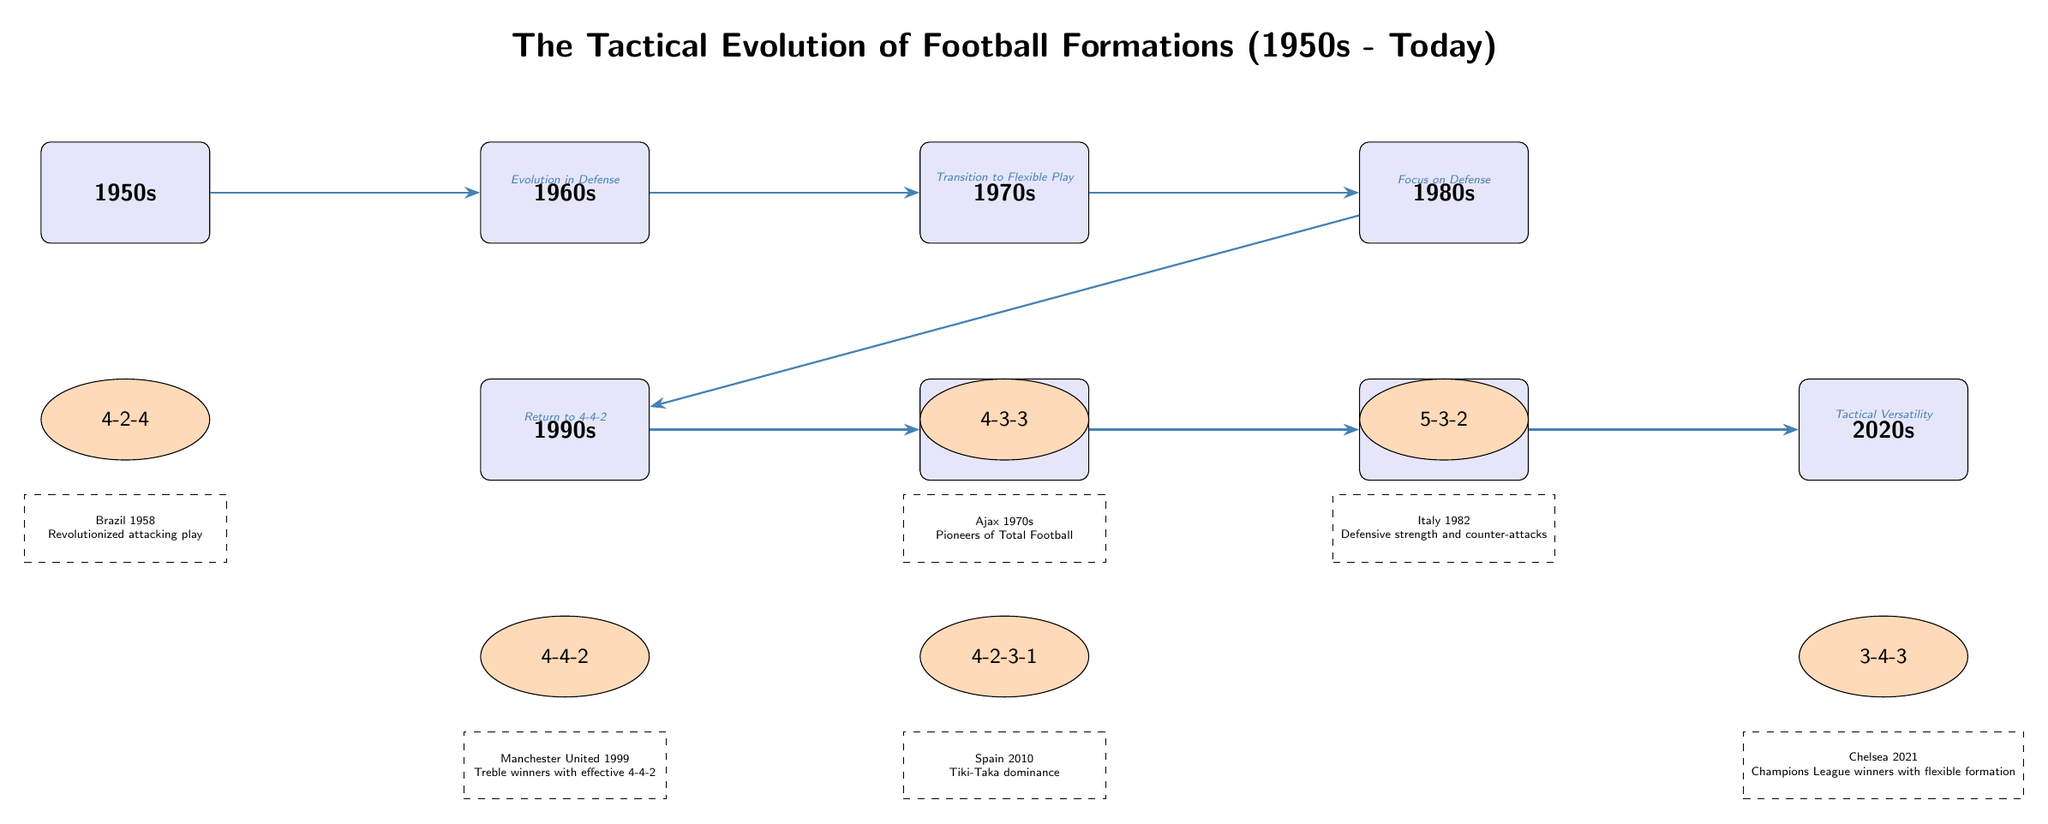What football formation is associated with the 1950s? The formation listed beneath the 1950s node in the diagram is 4-2-4. This directly relates to the node indicating the era.
Answer: 4-2-4 Which strategic change links the 1960s to the 1970s? The diagram shows an edge connecting the 1960s and 1970s with the label "Transition to Flexible Play." This indicates the strategic evolution from one era to the next.
Answer: Transition to Flexible Play What is the formation demonstrated during the 1990s? Under the 1990s node, the formation depicted is 4-4-2, as seen in the diagram.
Answer: 4-4-2 Which team is highlighted as a pioneer in Total Football during the 1970s? The example node below the 4-3-3 formation for the 1970s identifies Ajax 1970s as the pioneers of Total Football in that era.
Answer: Ajax 1970s How many edges are there in the diagram? By counting the connections between the era nodes, there are a total of seven edges shown connecting the different strategic changes.
Answer: 7 What formation is associated with tactical versatility in the 2020s? The diagram indicates that the 3-4-3 formation is represented beneath the 2020s node, linking it to tactical versatility.
Answer: 3-4-3 What strategic evolution is indicated between the 2000s and 2010s? The edge connecting the 2000s to the 2010s is labeled "Possession Play," showing that this was the strategic focus of that transition.
Answer: Possession Play What is the significance of the 5-3-2 formation? The 5-3-2 formation under the 1980s node reflects a focus on defensive strength, as described in the context of that era in the diagram.
Answer: Focus on Defense 